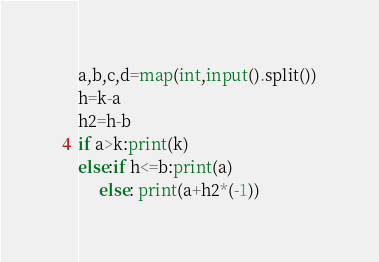<code> <loc_0><loc_0><loc_500><loc_500><_Python_>a,b,c,d=map(int,input().split())
h=k-a
h2=h-b
if a>k:print(k)
else:if h<=b:print(a)
     else: print(a+h2*(-1))</code> 